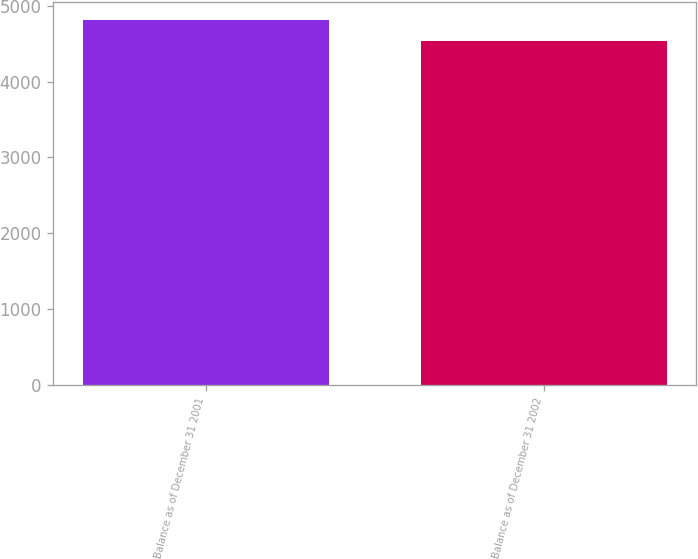Convert chart to OTSL. <chart><loc_0><loc_0><loc_500><loc_500><bar_chart><fcel>Balance as of December 31 2001<fcel>Balance as of December 31 2002<nl><fcel>4810<fcel>4528<nl></chart> 